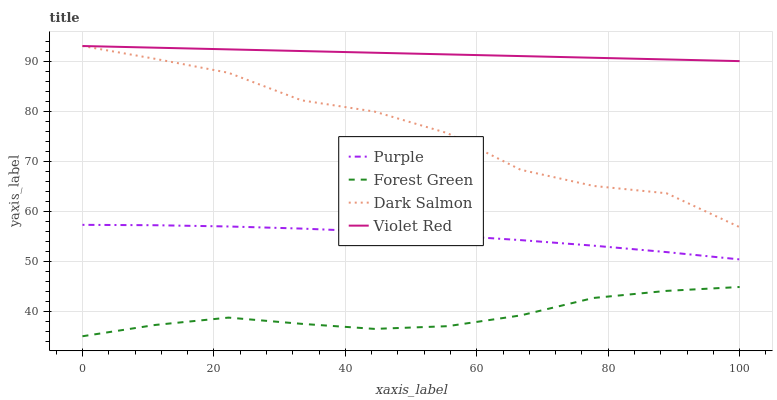Does Forest Green have the minimum area under the curve?
Answer yes or no. Yes. Does Violet Red have the maximum area under the curve?
Answer yes or no. Yes. Does Violet Red have the minimum area under the curve?
Answer yes or no. No. Does Forest Green have the maximum area under the curve?
Answer yes or no. No. Is Violet Red the smoothest?
Answer yes or no. Yes. Is Dark Salmon the roughest?
Answer yes or no. Yes. Is Forest Green the smoothest?
Answer yes or no. No. Is Forest Green the roughest?
Answer yes or no. No. Does Violet Red have the lowest value?
Answer yes or no. No. Does Dark Salmon have the highest value?
Answer yes or no. Yes. Does Forest Green have the highest value?
Answer yes or no. No. Is Forest Green less than Dark Salmon?
Answer yes or no. Yes. Is Purple greater than Forest Green?
Answer yes or no. Yes. Does Dark Salmon intersect Violet Red?
Answer yes or no. Yes. Is Dark Salmon less than Violet Red?
Answer yes or no. No. Is Dark Salmon greater than Violet Red?
Answer yes or no. No. Does Forest Green intersect Dark Salmon?
Answer yes or no. No. 